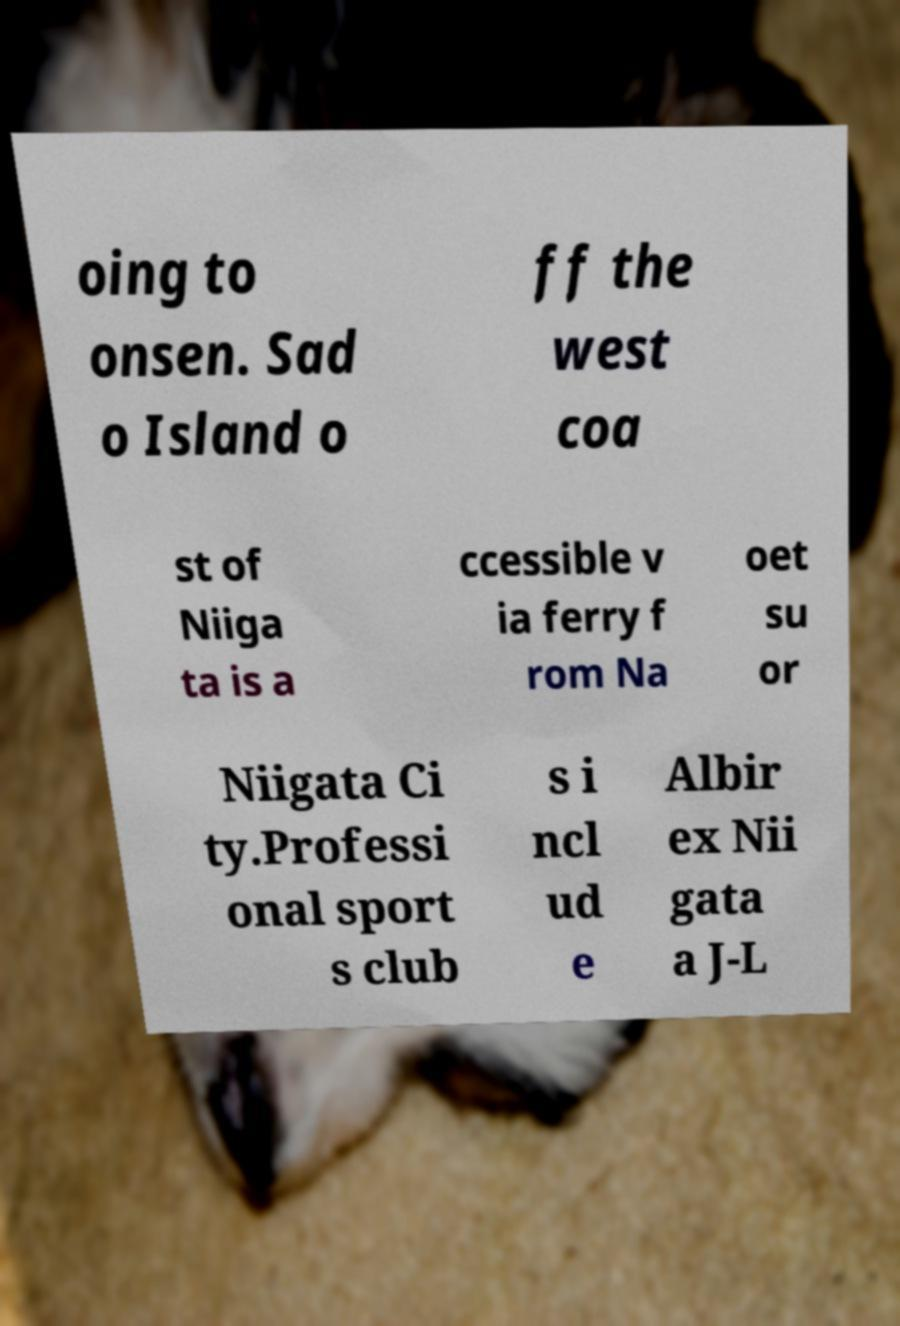I need the written content from this picture converted into text. Can you do that? oing to onsen. Sad o Island o ff the west coa st of Niiga ta is a ccessible v ia ferry f rom Na oet su or Niigata Ci ty.Professi onal sport s club s i ncl ud e Albir ex Nii gata a J-L 